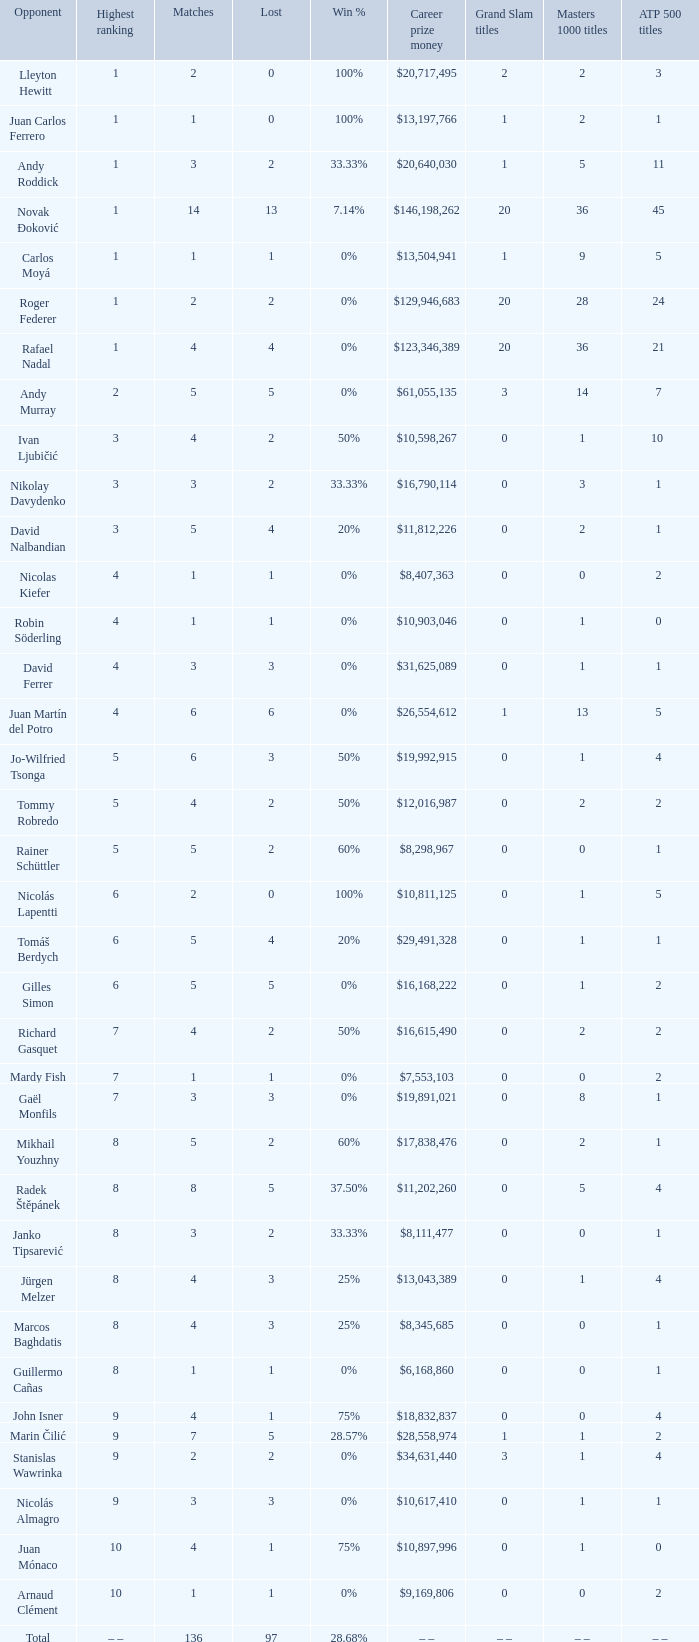What is the smallest number of Matches with less than 97 losses and a Win rate of 28.68%? None. 